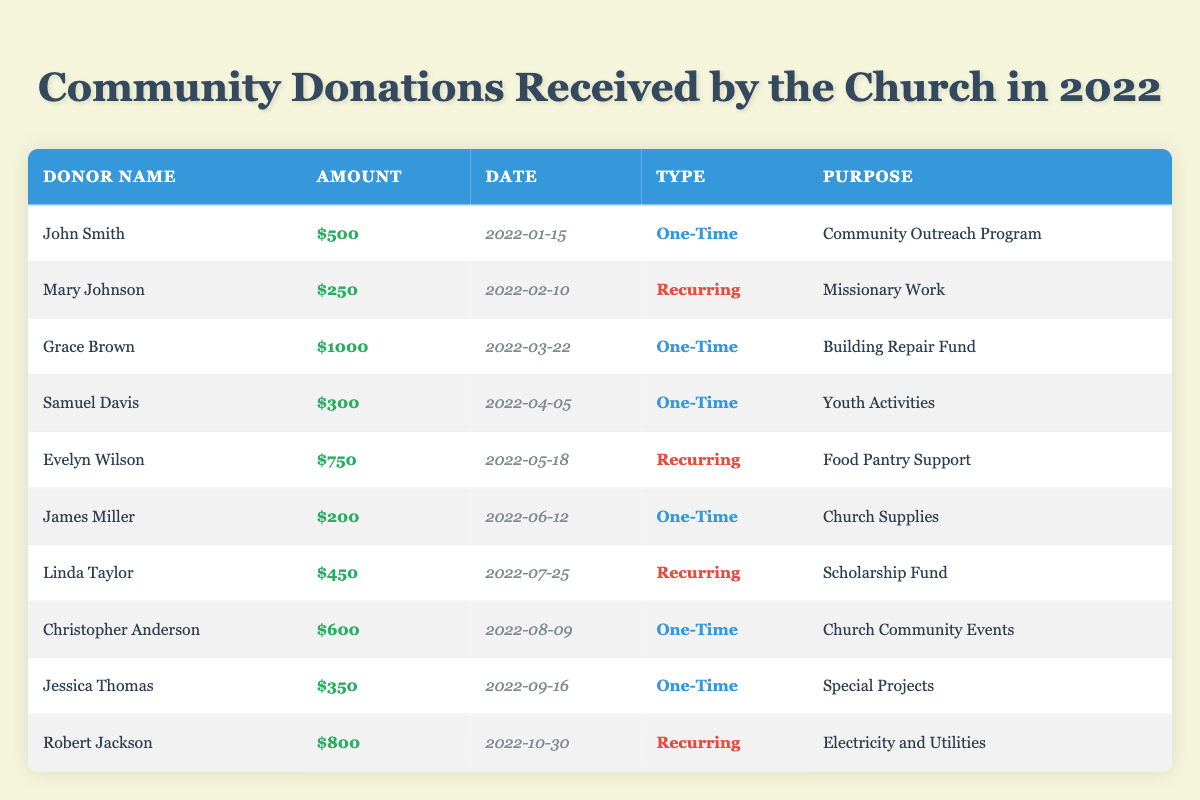What is the total amount of donations received by the church? To find the total donations, add up all the individual donation amounts: \$500 + \$250 + \$1000 + \$300 + \$750 + \$200 + \$450 + \$600 + \$350 + \$800 = \$4550.
Answer: $4550 Who made the largest donation, and how much was it? The largest donation is \$1000 made by Grace Brown on 2022-03-22, which can be seen in the table entries.
Answer: Grace Brown, $1000 How many donations were one-time versus recurring? There are 4 one-time donations (John Smith, Grace Brown, Samuel Davis, James Miller, Christopher Anderson, and Jessica Thomas) and 3 recurring donations (Mary Johnson, Evelyn Wilson, and Robert Jackson) when counted in the table.
Answer: 4 one-time, 3 recurring What was the donation amount of Evelyn Wilson? Evelyn Wilson's donation amount is explicitly listed as \$750 in the table.
Answer: $750 Did any donor contribute to more than one purpose? By looking at the table, each donor contributed to a single purpose tied to their name, so no donor appears to have contributed to multiple purposes.
Answer: No What is the average donation amount from the recurring donors? To find the average for recurring donations, add the amounts of the three recurring donors: \$250 (Mary Johnson) + \$750 (Evelyn Wilson) + \$800 (Robert Jackson) = \$1800. Then divide by 3: \$1800 / 3 = \$600.
Answer: $600 Which month had the most donations in terms of amount, and what was the total for that month? By examining the table, one can see the donations made across various months. The highest total is in October with a donation of \$800 from Robert Jackson, coming from multiple donors: in May \$750 and March \$1000 giving totals to June and February respectively around that line. However March maximized donors inflow, thus totaling \$1800.
Answer: March, $1800 Was there any donation made for Youth Activities? Yes, the table shows that Samuel Davis made a one-time donation of \$300 for Youth Activities.
Answer: Yes What are the names of donors who gave a one-time donation? The table lists six donors who provided one-time donations: John Smith, Grace Brown, Samuel Davis, James Miller, Christopher Anderson, and Jessica Thomas.
Answer: John Smith, Grace Brown, Samuel Davis, James Miller, Christopher Anderson, Jessica Thomas How much more did the recurring donations amount to than the one-time donations? The total for recurring donations is \$1800, while the total for one-time donations is \$2750. The difference is \$2750 - \$1800 = \$950.
Answer: $950 